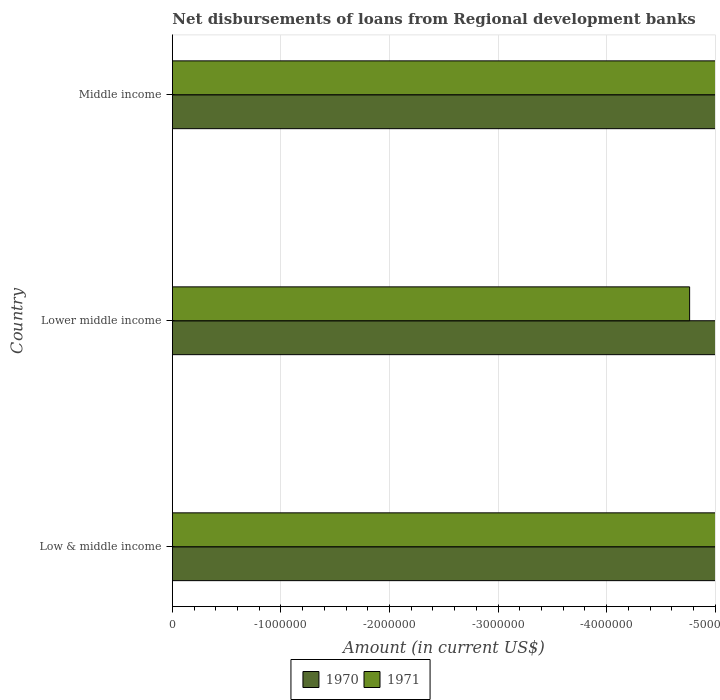How many different coloured bars are there?
Make the answer very short. 0. How many bars are there on the 1st tick from the top?
Ensure brevity in your answer.  0. How many bars are there on the 2nd tick from the bottom?
Ensure brevity in your answer.  0. What is the label of the 1st group of bars from the top?
Offer a terse response. Middle income. In how many cases, is the number of bars for a given country not equal to the number of legend labels?
Make the answer very short. 3. What is the amount of disbursements of loans from regional development banks in 1971 in Lower middle income?
Make the answer very short. 0. What is the total amount of disbursements of loans from regional development banks in 1970 in the graph?
Offer a very short reply. 0. What is the difference between the amount of disbursements of loans from regional development banks in 1970 in Lower middle income and the amount of disbursements of loans from regional development banks in 1971 in Low & middle income?
Your answer should be compact. 0. Are all the bars in the graph horizontal?
Your answer should be compact. Yes. How many countries are there in the graph?
Your answer should be compact. 3. What is the difference between two consecutive major ticks on the X-axis?
Provide a succinct answer. 1.00e+06. Does the graph contain any zero values?
Your response must be concise. Yes. Does the graph contain grids?
Offer a terse response. Yes. How are the legend labels stacked?
Provide a succinct answer. Horizontal. What is the title of the graph?
Your answer should be very brief. Net disbursements of loans from Regional development banks. What is the label or title of the X-axis?
Make the answer very short. Amount (in current US$). What is the label or title of the Y-axis?
Offer a very short reply. Country. What is the Amount (in current US$) in 1970 in Low & middle income?
Offer a very short reply. 0. What is the Amount (in current US$) in 1971 in Lower middle income?
Ensure brevity in your answer.  0. What is the Amount (in current US$) in 1970 in Middle income?
Offer a terse response. 0. What is the total Amount (in current US$) of 1971 in the graph?
Offer a terse response. 0. 